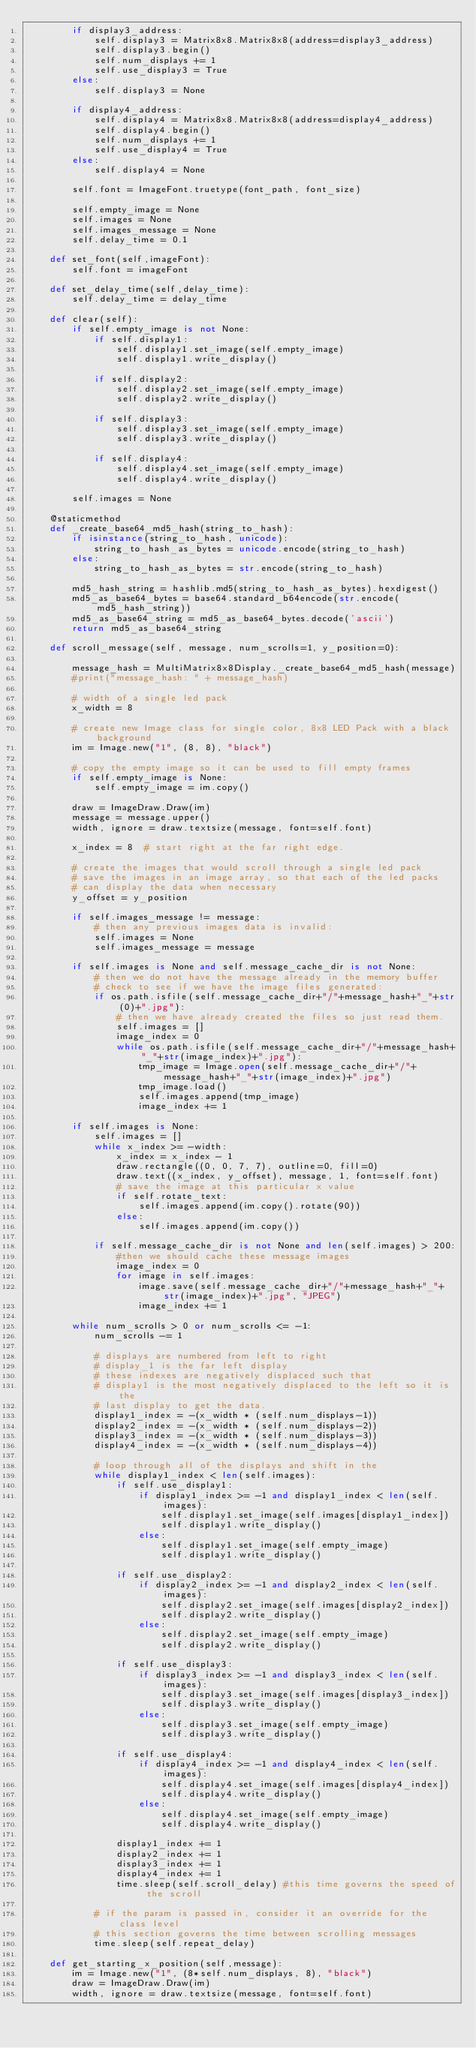Convert code to text. <code><loc_0><loc_0><loc_500><loc_500><_Python_>        if display3_address:
            self.display3 = Matrix8x8.Matrix8x8(address=display3_address)
            self.display3.begin()
            self.num_displays += 1
            self.use_display3 = True
        else:
            self.display3 = None

        if display4_address:
            self.display4 = Matrix8x8.Matrix8x8(address=display4_address)
            self.display4.begin()
            self.num_displays += 1
            self.use_display4 = True
        else:
            self.display4 = None

        self.font = ImageFont.truetype(font_path, font_size)

        self.empty_image = None
        self.images = None
        self.images_message = None
        self.delay_time = 0.1

    def set_font(self,imageFont):
        self.font = imageFont

    def set_delay_time(self,delay_time):
        self.delay_time = delay_time

    def clear(self):
        if self.empty_image is not None:
            if self.display1:
                self.display1.set_image(self.empty_image)
                self.display1.write_display()

            if self.display2:
                self.display2.set_image(self.empty_image)
                self.display2.write_display()

            if self.display3:
                self.display3.set_image(self.empty_image)
                self.display3.write_display()

            if self.display4:
                self.display4.set_image(self.empty_image)
                self.display4.write_display()

        self.images = None

    @staticmethod
    def _create_base64_md5_hash(string_to_hash):
        if isinstance(string_to_hash, unicode):
            string_to_hash_as_bytes = unicode.encode(string_to_hash)
        else:
            string_to_hash_as_bytes = str.encode(string_to_hash)

        md5_hash_string = hashlib.md5(string_to_hash_as_bytes).hexdigest()
        md5_as_base64_bytes = base64.standard_b64encode(str.encode(md5_hash_string))
        md5_as_base64_string = md5_as_base64_bytes.decode('ascii')
        return md5_as_base64_string

    def scroll_message(self, message, num_scrolls=1, y_position=0):

        message_hash = MultiMatrix8x8Display._create_base64_md5_hash(message)
        #print("message_hash: " + message_hash)

        # width of a single led pack
        x_width = 8

        # create new Image class for single color, 8x8 LED Pack with a black background
        im = Image.new("1", (8, 8), "black")

        # copy the empty image so it can be used to fill empty frames
        if self.empty_image is None:
            self.empty_image = im.copy()

        draw = ImageDraw.Draw(im)
        message = message.upper()
        width, ignore = draw.textsize(message, font=self.font)

        x_index = 8  # start right at the far right edge.

        # create the images that would scroll through a single led pack
        # save the images in an image array, so that each of the led packs
        # can display the data when necessary
        y_offset = y_position

        if self.images_message != message:
            # then any previous images data is invalid:
            self.images = None
            self.images_message = message

        if self.images is None and self.message_cache_dir is not None:
            # then we do not have the message already in the memory buffer
            # check to see if we have the image files generated:
            if os.path.isfile(self.message_cache_dir+"/"+message_hash+"_"+str(0)+".jpg"):
                # then we have already created the files so just read them.
                self.images = []
                image_index = 0
                while os.path.isfile(self.message_cache_dir+"/"+message_hash+"_"+str(image_index)+".jpg"):
                    tmp_image = Image.open(self.message_cache_dir+"/"+message_hash+"_"+str(image_index)+".jpg")
                    tmp_image.load()
                    self.images.append(tmp_image)
                    image_index += 1

        if self.images is None:
            self.images = []
            while x_index >= -width:
                x_index = x_index - 1
                draw.rectangle((0, 0, 7, 7), outline=0, fill=0)
                draw.text((x_index, y_offset), message, 1, font=self.font)
                # save the image at this particular x value
                if self.rotate_text:
                    self.images.append(im.copy().rotate(90))
                else:
                    self.images.append(im.copy())

            if self.message_cache_dir is not None and len(self.images) > 200:
                #then we should cache these message images
                image_index = 0
                for image in self.images:
                    image.save(self.message_cache_dir+"/"+message_hash+"_"+str(image_index)+".jpg", "JPEG")
                    image_index += 1

        while num_scrolls > 0 or num_scrolls <= -1:
            num_scrolls -= 1

            # displays are numbered from left to right
            # display_1 is the far left display
            # these indexes are negatively displaced such that
            # display1 is the most negatively displaced to the left so it is the
            # last display to get the data.
            display1_index = -(x_width * (self.num_displays-1))
            display2_index = -(x_width * (self.num_displays-2))
            display3_index = -(x_width * (self.num_displays-3))
            display4_index = -(x_width * (self.num_displays-4))

            # loop through all of the displays and shift in the
            while display1_index < len(self.images):
                if self.use_display1:
                    if display1_index >= -1 and display1_index < len(self.images):
                        self.display1.set_image(self.images[display1_index])
                        self.display1.write_display()
                    else:
                        self.display1.set_image(self.empty_image)
                        self.display1.write_display()

                if self.use_display2:
                    if display2_index >= -1 and display2_index < len(self.images):
                        self.display2.set_image(self.images[display2_index])
                        self.display2.write_display()
                    else:
                        self.display2.set_image(self.empty_image)
                        self.display2.write_display()

                if self.use_display3:
                    if display3_index >= -1 and display3_index < len(self.images):
                        self.display3.set_image(self.images[display3_index])
                        self.display3.write_display()
                    else:
                        self.display3.set_image(self.empty_image)
                        self.display3.write_display()

                if self.use_display4:
                    if display4_index >= -1 and display4_index < len(self.images):
                        self.display4.set_image(self.images[display4_index])
                        self.display4.write_display()
                    else:
                        self.display4.set_image(self.empty_image)
                        self.display4.write_display()

                display1_index += 1
                display2_index += 1
                display3_index += 1
                display4_index += 1
                time.sleep(self.scroll_delay) #this time governs the speed of the scroll

            # if the param is passed in, consider it an override for the class level
            # this section governs the time between scrolling messages
            time.sleep(self.repeat_delay)

    def get_starting_x_position(self,message):
        im = Image.new("1", (8*self.num_displays, 8), "black")
        draw = ImageDraw.Draw(im)
        width, ignore = draw.textsize(message, font=self.font)</code> 